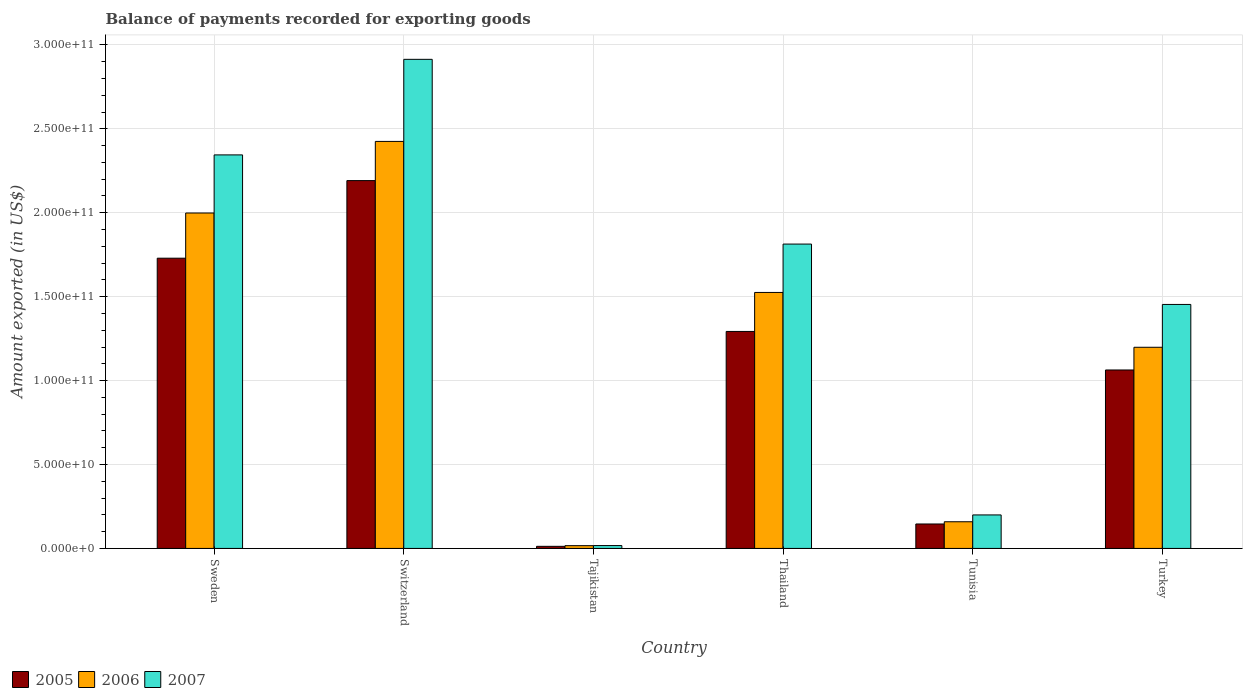How many bars are there on the 3rd tick from the left?
Keep it short and to the point. 3. What is the amount exported in 2007 in Turkey?
Provide a short and direct response. 1.45e+11. Across all countries, what is the maximum amount exported in 2007?
Keep it short and to the point. 2.91e+11. Across all countries, what is the minimum amount exported in 2006?
Your response must be concise. 1.65e+09. In which country was the amount exported in 2006 maximum?
Provide a succinct answer. Switzerland. In which country was the amount exported in 2007 minimum?
Provide a succinct answer. Tajikistan. What is the total amount exported in 2005 in the graph?
Ensure brevity in your answer.  6.44e+11. What is the difference between the amount exported in 2006 in Switzerland and that in Tajikistan?
Give a very brief answer. 2.41e+11. What is the difference between the amount exported in 2006 in Thailand and the amount exported in 2005 in Tajikistan?
Your answer should be very brief. 1.51e+11. What is the average amount exported in 2006 per country?
Offer a terse response. 1.22e+11. What is the difference between the amount exported of/in 2005 and amount exported of/in 2007 in Thailand?
Provide a short and direct response. -5.21e+1. What is the ratio of the amount exported in 2005 in Sweden to that in Tunisia?
Offer a terse response. 11.87. Is the amount exported in 2006 in Tajikistan less than that in Tunisia?
Provide a succinct answer. Yes. What is the difference between the highest and the second highest amount exported in 2005?
Give a very brief answer. 4.62e+1. What is the difference between the highest and the lowest amount exported in 2006?
Provide a short and direct response. 2.41e+11. In how many countries, is the amount exported in 2005 greater than the average amount exported in 2005 taken over all countries?
Ensure brevity in your answer.  3. Is the sum of the amount exported in 2005 in Tajikistan and Turkey greater than the maximum amount exported in 2007 across all countries?
Keep it short and to the point. No. What does the 3rd bar from the left in Thailand represents?
Keep it short and to the point. 2007. What does the 2nd bar from the right in Tunisia represents?
Provide a short and direct response. 2006. Is it the case that in every country, the sum of the amount exported in 2007 and amount exported in 2006 is greater than the amount exported in 2005?
Give a very brief answer. Yes. Are all the bars in the graph horizontal?
Provide a succinct answer. No. How many countries are there in the graph?
Offer a terse response. 6. What is the difference between two consecutive major ticks on the Y-axis?
Your response must be concise. 5.00e+1. Are the values on the major ticks of Y-axis written in scientific E-notation?
Keep it short and to the point. Yes. Does the graph contain grids?
Your answer should be very brief. Yes. How are the legend labels stacked?
Provide a succinct answer. Horizontal. What is the title of the graph?
Give a very brief answer. Balance of payments recorded for exporting goods. Does "2013" appear as one of the legend labels in the graph?
Provide a short and direct response. No. What is the label or title of the X-axis?
Offer a very short reply. Country. What is the label or title of the Y-axis?
Provide a short and direct response. Amount exported (in US$). What is the Amount exported (in US$) of 2005 in Sweden?
Offer a terse response. 1.73e+11. What is the Amount exported (in US$) in 2006 in Sweden?
Offer a very short reply. 2.00e+11. What is the Amount exported (in US$) in 2007 in Sweden?
Your answer should be very brief. 2.34e+11. What is the Amount exported (in US$) of 2005 in Switzerland?
Keep it short and to the point. 2.19e+11. What is the Amount exported (in US$) in 2006 in Switzerland?
Make the answer very short. 2.43e+11. What is the Amount exported (in US$) in 2007 in Switzerland?
Ensure brevity in your answer.  2.91e+11. What is the Amount exported (in US$) of 2005 in Tajikistan?
Provide a short and direct response. 1.25e+09. What is the Amount exported (in US$) of 2006 in Tajikistan?
Give a very brief answer. 1.65e+09. What is the Amount exported (in US$) in 2007 in Tajikistan?
Your response must be concise. 1.71e+09. What is the Amount exported (in US$) in 2005 in Thailand?
Provide a short and direct response. 1.29e+11. What is the Amount exported (in US$) in 2006 in Thailand?
Give a very brief answer. 1.53e+11. What is the Amount exported (in US$) in 2007 in Thailand?
Offer a very short reply. 1.81e+11. What is the Amount exported (in US$) in 2005 in Tunisia?
Your response must be concise. 1.46e+1. What is the Amount exported (in US$) of 2006 in Tunisia?
Your response must be concise. 1.59e+1. What is the Amount exported (in US$) in 2007 in Tunisia?
Your answer should be very brief. 2.00e+1. What is the Amount exported (in US$) in 2005 in Turkey?
Give a very brief answer. 1.06e+11. What is the Amount exported (in US$) of 2006 in Turkey?
Your answer should be compact. 1.20e+11. What is the Amount exported (in US$) of 2007 in Turkey?
Offer a very short reply. 1.45e+11. Across all countries, what is the maximum Amount exported (in US$) of 2005?
Provide a succinct answer. 2.19e+11. Across all countries, what is the maximum Amount exported (in US$) of 2006?
Make the answer very short. 2.43e+11. Across all countries, what is the maximum Amount exported (in US$) of 2007?
Offer a terse response. 2.91e+11. Across all countries, what is the minimum Amount exported (in US$) of 2005?
Provide a succinct answer. 1.25e+09. Across all countries, what is the minimum Amount exported (in US$) in 2006?
Make the answer very short. 1.65e+09. Across all countries, what is the minimum Amount exported (in US$) in 2007?
Keep it short and to the point. 1.71e+09. What is the total Amount exported (in US$) of 2005 in the graph?
Provide a succinct answer. 6.44e+11. What is the total Amount exported (in US$) in 2006 in the graph?
Give a very brief answer. 7.32e+11. What is the total Amount exported (in US$) in 2007 in the graph?
Make the answer very short. 8.74e+11. What is the difference between the Amount exported (in US$) of 2005 in Sweden and that in Switzerland?
Provide a succinct answer. -4.62e+1. What is the difference between the Amount exported (in US$) in 2006 in Sweden and that in Switzerland?
Provide a short and direct response. -4.27e+1. What is the difference between the Amount exported (in US$) in 2007 in Sweden and that in Switzerland?
Keep it short and to the point. -5.69e+1. What is the difference between the Amount exported (in US$) of 2005 in Sweden and that in Tajikistan?
Provide a short and direct response. 1.72e+11. What is the difference between the Amount exported (in US$) of 2006 in Sweden and that in Tajikistan?
Provide a succinct answer. 1.98e+11. What is the difference between the Amount exported (in US$) in 2007 in Sweden and that in Tajikistan?
Make the answer very short. 2.33e+11. What is the difference between the Amount exported (in US$) of 2005 in Sweden and that in Thailand?
Give a very brief answer. 4.36e+1. What is the difference between the Amount exported (in US$) in 2006 in Sweden and that in Thailand?
Provide a succinct answer. 4.73e+1. What is the difference between the Amount exported (in US$) in 2007 in Sweden and that in Thailand?
Make the answer very short. 5.31e+1. What is the difference between the Amount exported (in US$) of 2005 in Sweden and that in Tunisia?
Make the answer very short. 1.58e+11. What is the difference between the Amount exported (in US$) in 2006 in Sweden and that in Tunisia?
Offer a terse response. 1.84e+11. What is the difference between the Amount exported (in US$) in 2007 in Sweden and that in Tunisia?
Your answer should be very brief. 2.15e+11. What is the difference between the Amount exported (in US$) of 2005 in Sweden and that in Turkey?
Your answer should be very brief. 6.66e+1. What is the difference between the Amount exported (in US$) of 2006 in Sweden and that in Turkey?
Offer a terse response. 8.00e+1. What is the difference between the Amount exported (in US$) of 2007 in Sweden and that in Turkey?
Keep it short and to the point. 8.91e+1. What is the difference between the Amount exported (in US$) of 2005 in Switzerland and that in Tajikistan?
Provide a succinct answer. 2.18e+11. What is the difference between the Amount exported (in US$) in 2006 in Switzerland and that in Tajikistan?
Your answer should be very brief. 2.41e+11. What is the difference between the Amount exported (in US$) in 2007 in Switzerland and that in Tajikistan?
Your answer should be compact. 2.90e+11. What is the difference between the Amount exported (in US$) of 2005 in Switzerland and that in Thailand?
Your answer should be very brief. 8.99e+1. What is the difference between the Amount exported (in US$) in 2006 in Switzerland and that in Thailand?
Your answer should be compact. 9.00e+1. What is the difference between the Amount exported (in US$) of 2007 in Switzerland and that in Thailand?
Offer a very short reply. 1.10e+11. What is the difference between the Amount exported (in US$) of 2005 in Switzerland and that in Tunisia?
Provide a succinct answer. 2.05e+11. What is the difference between the Amount exported (in US$) of 2006 in Switzerland and that in Tunisia?
Offer a very short reply. 2.27e+11. What is the difference between the Amount exported (in US$) of 2007 in Switzerland and that in Tunisia?
Offer a very short reply. 2.71e+11. What is the difference between the Amount exported (in US$) in 2005 in Switzerland and that in Turkey?
Make the answer very short. 1.13e+11. What is the difference between the Amount exported (in US$) of 2006 in Switzerland and that in Turkey?
Keep it short and to the point. 1.23e+11. What is the difference between the Amount exported (in US$) of 2007 in Switzerland and that in Turkey?
Provide a succinct answer. 1.46e+11. What is the difference between the Amount exported (in US$) of 2005 in Tajikistan and that in Thailand?
Provide a succinct answer. -1.28e+11. What is the difference between the Amount exported (in US$) in 2006 in Tajikistan and that in Thailand?
Offer a terse response. -1.51e+11. What is the difference between the Amount exported (in US$) in 2007 in Tajikistan and that in Thailand?
Your answer should be very brief. -1.80e+11. What is the difference between the Amount exported (in US$) of 2005 in Tajikistan and that in Tunisia?
Make the answer very short. -1.33e+1. What is the difference between the Amount exported (in US$) of 2006 in Tajikistan and that in Tunisia?
Offer a terse response. -1.42e+1. What is the difference between the Amount exported (in US$) in 2007 in Tajikistan and that in Tunisia?
Your answer should be compact. -1.83e+1. What is the difference between the Amount exported (in US$) in 2005 in Tajikistan and that in Turkey?
Offer a very short reply. -1.05e+11. What is the difference between the Amount exported (in US$) in 2006 in Tajikistan and that in Turkey?
Give a very brief answer. -1.18e+11. What is the difference between the Amount exported (in US$) of 2007 in Tajikistan and that in Turkey?
Your answer should be very brief. -1.44e+11. What is the difference between the Amount exported (in US$) in 2005 in Thailand and that in Tunisia?
Ensure brevity in your answer.  1.15e+11. What is the difference between the Amount exported (in US$) in 2006 in Thailand and that in Tunisia?
Offer a very short reply. 1.37e+11. What is the difference between the Amount exported (in US$) in 2007 in Thailand and that in Tunisia?
Make the answer very short. 1.61e+11. What is the difference between the Amount exported (in US$) of 2005 in Thailand and that in Turkey?
Provide a short and direct response. 2.30e+1. What is the difference between the Amount exported (in US$) of 2006 in Thailand and that in Turkey?
Your answer should be very brief. 3.27e+1. What is the difference between the Amount exported (in US$) in 2007 in Thailand and that in Turkey?
Make the answer very short. 3.60e+1. What is the difference between the Amount exported (in US$) of 2005 in Tunisia and that in Turkey?
Your answer should be very brief. -9.18e+1. What is the difference between the Amount exported (in US$) of 2006 in Tunisia and that in Turkey?
Your answer should be very brief. -1.04e+11. What is the difference between the Amount exported (in US$) of 2007 in Tunisia and that in Turkey?
Provide a short and direct response. -1.25e+11. What is the difference between the Amount exported (in US$) in 2005 in Sweden and the Amount exported (in US$) in 2006 in Switzerland?
Provide a succinct answer. -6.96e+1. What is the difference between the Amount exported (in US$) of 2005 in Sweden and the Amount exported (in US$) of 2007 in Switzerland?
Give a very brief answer. -1.18e+11. What is the difference between the Amount exported (in US$) in 2006 in Sweden and the Amount exported (in US$) in 2007 in Switzerland?
Offer a very short reply. -9.16e+1. What is the difference between the Amount exported (in US$) in 2005 in Sweden and the Amount exported (in US$) in 2006 in Tajikistan?
Make the answer very short. 1.71e+11. What is the difference between the Amount exported (in US$) in 2005 in Sweden and the Amount exported (in US$) in 2007 in Tajikistan?
Ensure brevity in your answer.  1.71e+11. What is the difference between the Amount exported (in US$) of 2006 in Sweden and the Amount exported (in US$) of 2007 in Tajikistan?
Offer a terse response. 1.98e+11. What is the difference between the Amount exported (in US$) in 2005 in Sweden and the Amount exported (in US$) in 2006 in Thailand?
Your answer should be very brief. 2.04e+1. What is the difference between the Amount exported (in US$) of 2005 in Sweden and the Amount exported (in US$) of 2007 in Thailand?
Offer a terse response. -8.41e+09. What is the difference between the Amount exported (in US$) in 2006 in Sweden and the Amount exported (in US$) in 2007 in Thailand?
Your answer should be very brief. 1.85e+1. What is the difference between the Amount exported (in US$) in 2005 in Sweden and the Amount exported (in US$) in 2006 in Tunisia?
Offer a terse response. 1.57e+11. What is the difference between the Amount exported (in US$) in 2005 in Sweden and the Amount exported (in US$) in 2007 in Tunisia?
Give a very brief answer. 1.53e+11. What is the difference between the Amount exported (in US$) in 2006 in Sweden and the Amount exported (in US$) in 2007 in Tunisia?
Offer a very short reply. 1.80e+11. What is the difference between the Amount exported (in US$) in 2005 in Sweden and the Amount exported (in US$) in 2006 in Turkey?
Make the answer very short. 5.31e+1. What is the difference between the Amount exported (in US$) of 2005 in Sweden and the Amount exported (in US$) of 2007 in Turkey?
Keep it short and to the point. 2.76e+1. What is the difference between the Amount exported (in US$) of 2006 in Sweden and the Amount exported (in US$) of 2007 in Turkey?
Your answer should be very brief. 5.45e+1. What is the difference between the Amount exported (in US$) in 2005 in Switzerland and the Amount exported (in US$) in 2006 in Tajikistan?
Provide a short and direct response. 2.18e+11. What is the difference between the Amount exported (in US$) of 2005 in Switzerland and the Amount exported (in US$) of 2007 in Tajikistan?
Keep it short and to the point. 2.17e+11. What is the difference between the Amount exported (in US$) of 2006 in Switzerland and the Amount exported (in US$) of 2007 in Tajikistan?
Provide a succinct answer. 2.41e+11. What is the difference between the Amount exported (in US$) in 2005 in Switzerland and the Amount exported (in US$) in 2006 in Thailand?
Offer a very short reply. 6.66e+1. What is the difference between the Amount exported (in US$) of 2005 in Switzerland and the Amount exported (in US$) of 2007 in Thailand?
Offer a terse response. 3.78e+1. What is the difference between the Amount exported (in US$) of 2006 in Switzerland and the Amount exported (in US$) of 2007 in Thailand?
Offer a terse response. 6.12e+1. What is the difference between the Amount exported (in US$) in 2005 in Switzerland and the Amount exported (in US$) in 2006 in Tunisia?
Offer a terse response. 2.03e+11. What is the difference between the Amount exported (in US$) of 2005 in Switzerland and the Amount exported (in US$) of 2007 in Tunisia?
Offer a terse response. 1.99e+11. What is the difference between the Amount exported (in US$) in 2006 in Switzerland and the Amount exported (in US$) in 2007 in Tunisia?
Make the answer very short. 2.23e+11. What is the difference between the Amount exported (in US$) in 2005 in Switzerland and the Amount exported (in US$) in 2006 in Turkey?
Give a very brief answer. 9.93e+1. What is the difference between the Amount exported (in US$) in 2005 in Switzerland and the Amount exported (in US$) in 2007 in Turkey?
Your response must be concise. 7.38e+1. What is the difference between the Amount exported (in US$) in 2006 in Switzerland and the Amount exported (in US$) in 2007 in Turkey?
Make the answer very short. 9.71e+1. What is the difference between the Amount exported (in US$) of 2005 in Tajikistan and the Amount exported (in US$) of 2006 in Thailand?
Keep it short and to the point. -1.51e+11. What is the difference between the Amount exported (in US$) of 2005 in Tajikistan and the Amount exported (in US$) of 2007 in Thailand?
Give a very brief answer. -1.80e+11. What is the difference between the Amount exported (in US$) in 2006 in Tajikistan and the Amount exported (in US$) in 2007 in Thailand?
Your response must be concise. -1.80e+11. What is the difference between the Amount exported (in US$) of 2005 in Tajikistan and the Amount exported (in US$) of 2006 in Tunisia?
Give a very brief answer. -1.46e+1. What is the difference between the Amount exported (in US$) of 2005 in Tajikistan and the Amount exported (in US$) of 2007 in Tunisia?
Provide a short and direct response. -1.87e+1. What is the difference between the Amount exported (in US$) of 2006 in Tajikistan and the Amount exported (in US$) of 2007 in Tunisia?
Your response must be concise. -1.83e+1. What is the difference between the Amount exported (in US$) of 2005 in Tajikistan and the Amount exported (in US$) of 2006 in Turkey?
Offer a terse response. -1.19e+11. What is the difference between the Amount exported (in US$) of 2005 in Tajikistan and the Amount exported (in US$) of 2007 in Turkey?
Ensure brevity in your answer.  -1.44e+11. What is the difference between the Amount exported (in US$) of 2006 in Tajikistan and the Amount exported (in US$) of 2007 in Turkey?
Ensure brevity in your answer.  -1.44e+11. What is the difference between the Amount exported (in US$) in 2005 in Thailand and the Amount exported (in US$) in 2006 in Tunisia?
Your response must be concise. 1.13e+11. What is the difference between the Amount exported (in US$) of 2005 in Thailand and the Amount exported (in US$) of 2007 in Tunisia?
Keep it short and to the point. 1.09e+11. What is the difference between the Amount exported (in US$) of 2006 in Thailand and the Amount exported (in US$) of 2007 in Tunisia?
Keep it short and to the point. 1.33e+11. What is the difference between the Amount exported (in US$) of 2005 in Thailand and the Amount exported (in US$) of 2006 in Turkey?
Offer a terse response. 9.43e+09. What is the difference between the Amount exported (in US$) of 2005 in Thailand and the Amount exported (in US$) of 2007 in Turkey?
Offer a terse response. -1.61e+1. What is the difference between the Amount exported (in US$) of 2006 in Thailand and the Amount exported (in US$) of 2007 in Turkey?
Your response must be concise. 7.15e+09. What is the difference between the Amount exported (in US$) of 2005 in Tunisia and the Amount exported (in US$) of 2006 in Turkey?
Your response must be concise. -1.05e+11. What is the difference between the Amount exported (in US$) of 2005 in Tunisia and the Amount exported (in US$) of 2007 in Turkey?
Provide a succinct answer. -1.31e+11. What is the difference between the Amount exported (in US$) of 2006 in Tunisia and the Amount exported (in US$) of 2007 in Turkey?
Offer a very short reply. -1.29e+11. What is the average Amount exported (in US$) of 2005 per country?
Your answer should be very brief. 1.07e+11. What is the average Amount exported (in US$) in 2006 per country?
Ensure brevity in your answer.  1.22e+11. What is the average Amount exported (in US$) of 2007 per country?
Make the answer very short. 1.46e+11. What is the difference between the Amount exported (in US$) in 2005 and Amount exported (in US$) in 2006 in Sweden?
Keep it short and to the point. -2.69e+1. What is the difference between the Amount exported (in US$) in 2005 and Amount exported (in US$) in 2007 in Sweden?
Provide a succinct answer. -6.15e+1. What is the difference between the Amount exported (in US$) in 2006 and Amount exported (in US$) in 2007 in Sweden?
Offer a very short reply. -3.46e+1. What is the difference between the Amount exported (in US$) of 2005 and Amount exported (in US$) of 2006 in Switzerland?
Ensure brevity in your answer.  -2.34e+1. What is the difference between the Amount exported (in US$) of 2005 and Amount exported (in US$) of 2007 in Switzerland?
Ensure brevity in your answer.  -7.23e+1. What is the difference between the Amount exported (in US$) in 2006 and Amount exported (in US$) in 2007 in Switzerland?
Ensure brevity in your answer.  -4.89e+1. What is the difference between the Amount exported (in US$) in 2005 and Amount exported (in US$) in 2006 in Tajikistan?
Your answer should be very brief. -3.92e+08. What is the difference between the Amount exported (in US$) in 2005 and Amount exported (in US$) in 2007 in Tajikistan?
Your response must be concise. -4.51e+08. What is the difference between the Amount exported (in US$) of 2006 and Amount exported (in US$) of 2007 in Tajikistan?
Make the answer very short. -5.96e+07. What is the difference between the Amount exported (in US$) in 2005 and Amount exported (in US$) in 2006 in Thailand?
Your response must be concise. -2.32e+1. What is the difference between the Amount exported (in US$) of 2005 and Amount exported (in US$) of 2007 in Thailand?
Your answer should be very brief. -5.21e+1. What is the difference between the Amount exported (in US$) of 2006 and Amount exported (in US$) of 2007 in Thailand?
Give a very brief answer. -2.88e+1. What is the difference between the Amount exported (in US$) in 2005 and Amount exported (in US$) in 2006 in Tunisia?
Keep it short and to the point. -1.32e+09. What is the difference between the Amount exported (in US$) of 2005 and Amount exported (in US$) of 2007 in Tunisia?
Make the answer very short. -5.40e+09. What is the difference between the Amount exported (in US$) of 2006 and Amount exported (in US$) of 2007 in Tunisia?
Provide a succinct answer. -4.07e+09. What is the difference between the Amount exported (in US$) of 2005 and Amount exported (in US$) of 2006 in Turkey?
Give a very brief answer. -1.35e+1. What is the difference between the Amount exported (in US$) of 2005 and Amount exported (in US$) of 2007 in Turkey?
Make the answer very short. -3.91e+1. What is the difference between the Amount exported (in US$) in 2006 and Amount exported (in US$) in 2007 in Turkey?
Give a very brief answer. -2.55e+1. What is the ratio of the Amount exported (in US$) in 2005 in Sweden to that in Switzerland?
Give a very brief answer. 0.79. What is the ratio of the Amount exported (in US$) of 2006 in Sweden to that in Switzerland?
Ensure brevity in your answer.  0.82. What is the ratio of the Amount exported (in US$) of 2007 in Sweden to that in Switzerland?
Your response must be concise. 0.8. What is the ratio of the Amount exported (in US$) of 2005 in Sweden to that in Tajikistan?
Your answer should be compact. 137.86. What is the ratio of the Amount exported (in US$) in 2006 in Sweden to that in Tajikistan?
Ensure brevity in your answer.  121.42. What is the ratio of the Amount exported (in US$) in 2007 in Sweden to that in Tajikistan?
Offer a terse response. 137.48. What is the ratio of the Amount exported (in US$) in 2005 in Sweden to that in Thailand?
Offer a very short reply. 1.34. What is the ratio of the Amount exported (in US$) of 2006 in Sweden to that in Thailand?
Offer a terse response. 1.31. What is the ratio of the Amount exported (in US$) of 2007 in Sweden to that in Thailand?
Your answer should be compact. 1.29. What is the ratio of the Amount exported (in US$) in 2005 in Sweden to that in Tunisia?
Give a very brief answer. 11.87. What is the ratio of the Amount exported (in US$) in 2006 in Sweden to that in Tunisia?
Ensure brevity in your answer.  12.58. What is the ratio of the Amount exported (in US$) in 2007 in Sweden to that in Tunisia?
Keep it short and to the point. 11.75. What is the ratio of the Amount exported (in US$) in 2005 in Sweden to that in Turkey?
Make the answer very short. 1.63. What is the ratio of the Amount exported (in US$) in 2006 in Sweden to that in Turkey?
Offer a very short reply. 1.67. What is the ratio of the Amount exported (in US$) of 2007 in Sweden to that in Turkey?
Ensure brevity in your answer.  1.61. What is the ratio of the Amount exported (in US$) in 2005 in Switzerland to that in Tajikistan?
Ensure brevity in your answer.  174.72. What is the ratio of the Amount exported (in US$) in 2006 in Switzerland to that in Tajikistan?
Provide a succinct answer. 147.34. What is the ratio of the Amount exported (in US$) in 2007 in Switzerland to that in Tajikistan?
Ensure brevity in your answer.  170.87. What is the ratio of the Amount exported (in US$) in 2005 in Switzerland to that in Thailand?
Offer a terse response. 1.7. What is the ratio of the Amount exported (in US$) of 2006 in Switzerland to that in Thailand?
Offer a very short reply. 1.59. What is the ratio of the Amount exported (in US$) of 2007 in Switzerland to that in Thailand?
Give a very brief answer. 1.61. What is the ratio of the Amount exported (in US$) of 2005 in Switzerland to that in Tunisia?
Make the answer very short. 15.04. What is the ratio of the Amount exported (in US$) in 2006 in Switzerland to that in Tunisia?
Make the answer very short. 15.26. What is the ratio of the Amount exported (in US$) of 2007 in Switzerland to that in Tunisia?
Give a very brief answer. 14.6. What is the ratio of the Amount exported (in US$) in 2005 in Switzerland to that in Turkey?
Ensure brevity in your answer.  2.06. What is the ratio of the Amount exported (in US$) in 2006 in Switzerland to that in Turkey?
Ensure brevity in your answer.  2.02. What is the ratio of the Amount exported (in US$) in 2007 in Switzerland to that in Turkey?
Your answer should be compact. 2. What is the ratio of the Amount exported (in US$) in 2005 in Tajikistan to that in Thailand?
Offer a very short reply. 0.01. What is the ratio of the Amount exported (in US$) in 2006 in Tajikistan to that in Thailand?
Your response must be concise. 0.01. What is the ratio of the Amount exported (in US$) in 2007 in Tajikistan to that in Thailand?
Make the answer very short. 0.01. What is the ratio of the Amount exported (in US$) in 2005 in Tajikistan to that in Tunisia?
Offer a terse response. 0.09. What is the ratio of the Amount exported (in US$) in 2006 in Tajikistan to that in Tunisia?
Your answer should be compact. 0.1. What is the ratio of the Amount exported (in US$) in 2007 in Tajikistan to that in Tunisia?
Your answer should be very brief. 0.09. What is the ratio of the Amount exported (in US$) of 2005 in Tajikistan to that in Turkey?
Provide a short and direct response. 0.01. What is the ratio of the Amount exported (in US$) in 2006 in Tajikistan to that in Turkey?
Your answer should be very brief. 0.01. What is the ratio of the Amount exported (in US$) of 2007 in Tajikistan to that in Turkey?
Ensure brevity in your answer.  0.01. What is the ratio of the Amount exported (in US$) of 2005 in Thailand to that in Tunisia?
Offer a very short reply. 8.88. What is the ratio of the Amount exported (in US$) in 2006 in Thailand to that in Tunisia?
Offer a very short reply. 9.6. What is the ratio of the Amount exported (in US$) of 2007 in Thailand to that in Tunisia?
Provide a succinct answer. 9.08. What is the ratio of the Amount exported (in US$) in 2005 in Thailand to that in Turkey?
Provide a succinct answer. 1.22. What is the ratio of the Amount exported (in US$) in 2006 in Thailand to that in Turkey?
Your response must be concise. 1.27. What is the ratio of the Amount exported (in US$) in 2007 in Thailand to that in Turkey?
Your answer should be very brief. 1.25. What is the ratio of the Amount exported (in US$) in 2005 in Tunisia to that in Turkey?
Make the answer very short. 0.14. What is the ratio of the Amount exported (in US$) of 2006 in Tunisia to that in Turkey?
Ensure brevity in your answer.  0.13. What is the ratio of the Amount exported (in US$) of 2007 in Tunisia to that in Turkey?
Make the answer very short. 0.14. What is the difference between the highest and the second highest Amount exported (in US$) in 2005?
Provide a short and direct response. 4.62e+1. What is the difference between the highest and the second highest Amount exported (in US$) in 2006?
Ensure brevity in your answer.  4.27e+1. What is the difference between the highest and the second highest Amount exported (in US$) in 2007?
Offer a very short reply. 5.69e+1. What is the difference between the highest and the lowest Amount exported (in US$) in 2005?
Offer a terse response. 2.18e+11. What is the difference between the highest and the lowest Amount exported (in US$) in 2006?
Your answer should be very brief. 2.41e+11. What is the difference between the highest and the lowest Amount exported (in US$) of 2007?
Keep it short and to the point. 2.90e+11. 